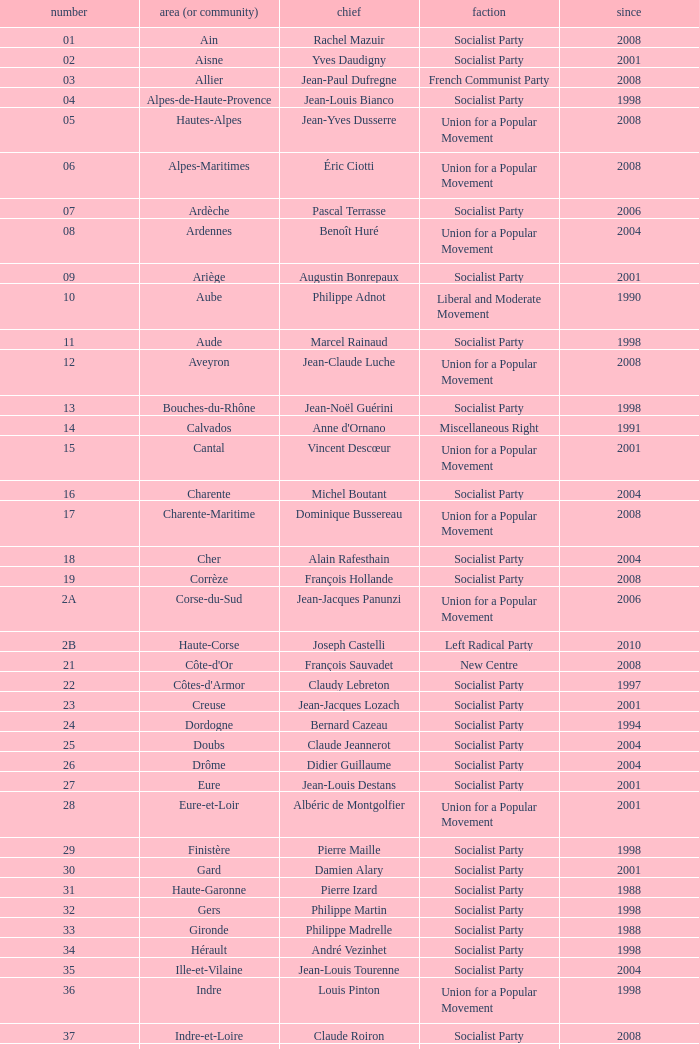What number corresponds to Presidet Yves Krattinger of the Socialist party? 70.0. 